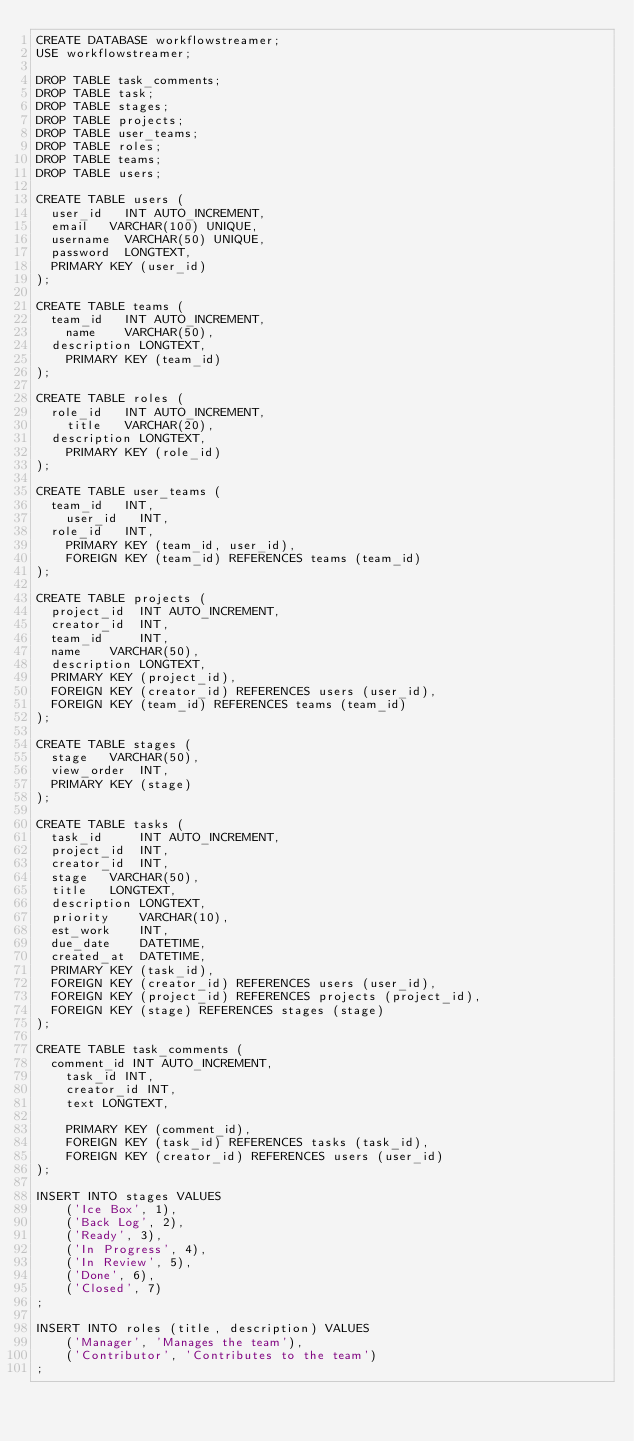Convert code to text. <code><loc_0><loc_0><loc_500><loc_500><_SQL_>CREATE DATABASE workflowstreamer;
USE workflowstreamer;

DROP TABLE task_comments;
DROP TABLE task;
DROP TABLE stages;
DROP TABLE projects;
DROP TABLE user_teams;
DROP TABLE roles;
DROP TABLE teams;
DROP TABLE users;

CREATE TABLE users (
	user_id		INT AUTO_INCREMENT,
	email		VARCHAR(100) UNIQUE,
	username	VARCHAR(50) UNIQUE,
	password	LONGTEXT,
	PRIMARY KEY (user_id)
);

CREATE TABLE teams (
	team_id 	INT AUTO_INCREMENT,
    name		VARCHAR(50),
	description	LONGTEXT,
    PRIMARY KEY (team_id)
);

CREATE TABLE roles (
	role_id 	INT AUTO_INCREMENT,
    title	 	VARCHAR(20),
	description	LONGTEXT,
    PRIMARY KEY (role_id)
);

CREATE TABLE user_teams (
	team_id 	INT,
    user_id 	INT,
	role_id		INT,
    PRIMARY KEY (team_id, user_id),
    FOREIGN KEY (team_id) REFERENCES teams (team_id)
);

CREATE TABLE projects (
	project_id 	INT AUTO_INCREMENT,
	creator_id 	INT,
	team_id     INT,
	name 		VARCHAR(50),
	description LONGTEXT,
	PRIMARY KEY (project_id),
	FOREIGN KEY (creator_id) REFERENCES users (user_id),
	FOREIGN KEY (team_id) REFERENCES teams (team_id)
);

CREATE TABLE stages (
	stage		VARCHAR(50),
	view_order  INT,
	PRIMARY KEY (stage)
);

CREATE TABLE tasks (
	task_id	    INT AUTO_INCREMENT,
	project_id	INT,
	creator_id	INT,
	stage		VARCHAR(50),
	title		LONGTEXT,
	description	LONGTEXT,
	priority    VARCHAR(10),
	est_work    INT,
	due_date    DATETIME,
	created_at	DATETIME,
	PRIMARY KEY (task_id),
	FOREIGN KEY (creator_id) REFERENCES users (user_id),
	FOREIGN KEY (project_id) REFERENCES projects (project_id),
	FOREIGN KEY (stage) REFERENCES stages (stage)
);

CREATE TABLE task_comments (
	comment_id INT AUTO_INCREMENT,
    task_id INT,
    creator_id INT,
    text LONGTEXT,

    PRIMARY KEY (comment_id),
    FOREIGN KEY (task_id) REFERENCES tasks (task_id),
    FOREIGN KEY (creator_id) REFERENCES users (user_id)
);

INSERT INTO stages VALUES
    ('Ice Box', 1),
    ('Back Log', 2),
    ('Ready', 3),
    ('In Progress', 4),
    ('In Review', 5),
    ('Done', 6),
    ('Closed', 7)
;

INSERT INTO roles (title, description) VALUES
    ('Manager', 'Manages the team'),
    ('Contributor', 'Contributes to the team')
;</code> 